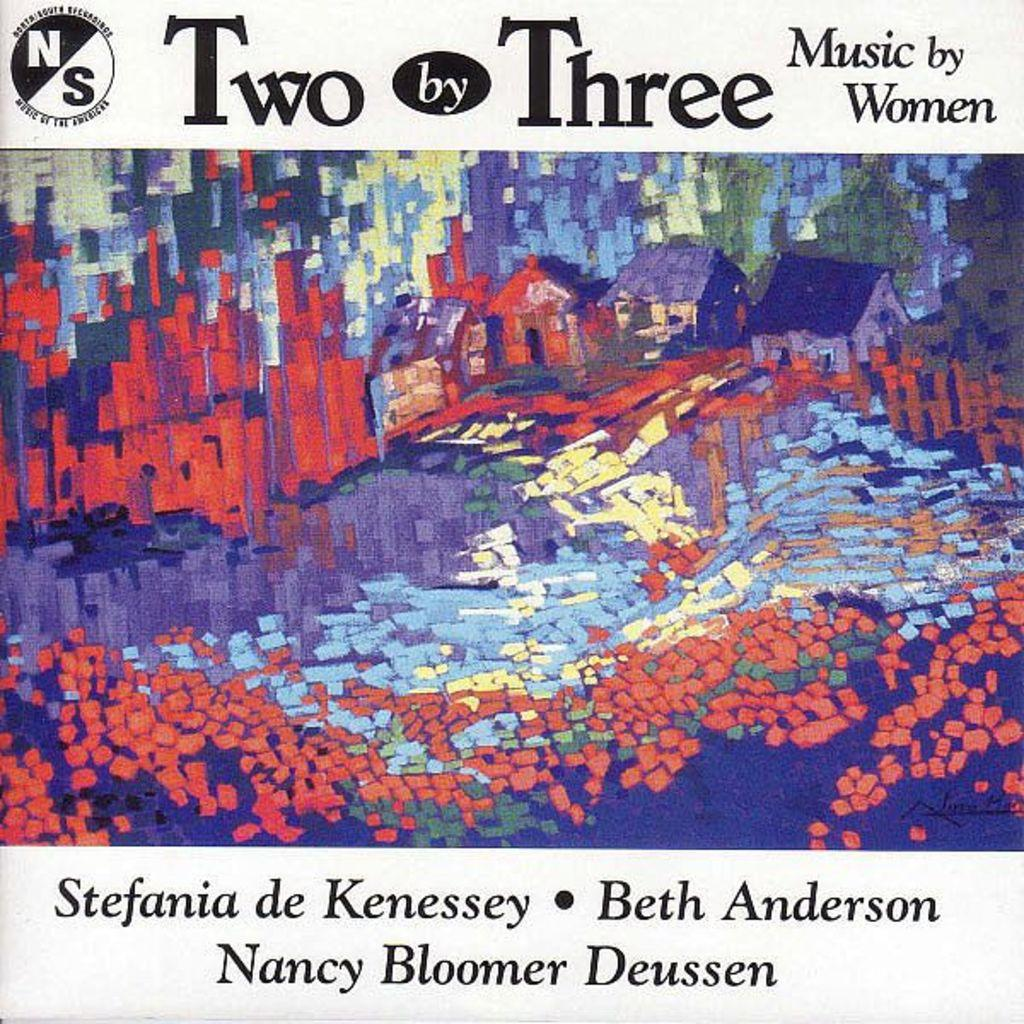<image>
Write a terse but informative summary of the picture. Poster showing some houses and the name "Nancy Bloomer Deussen" on the bottom. 